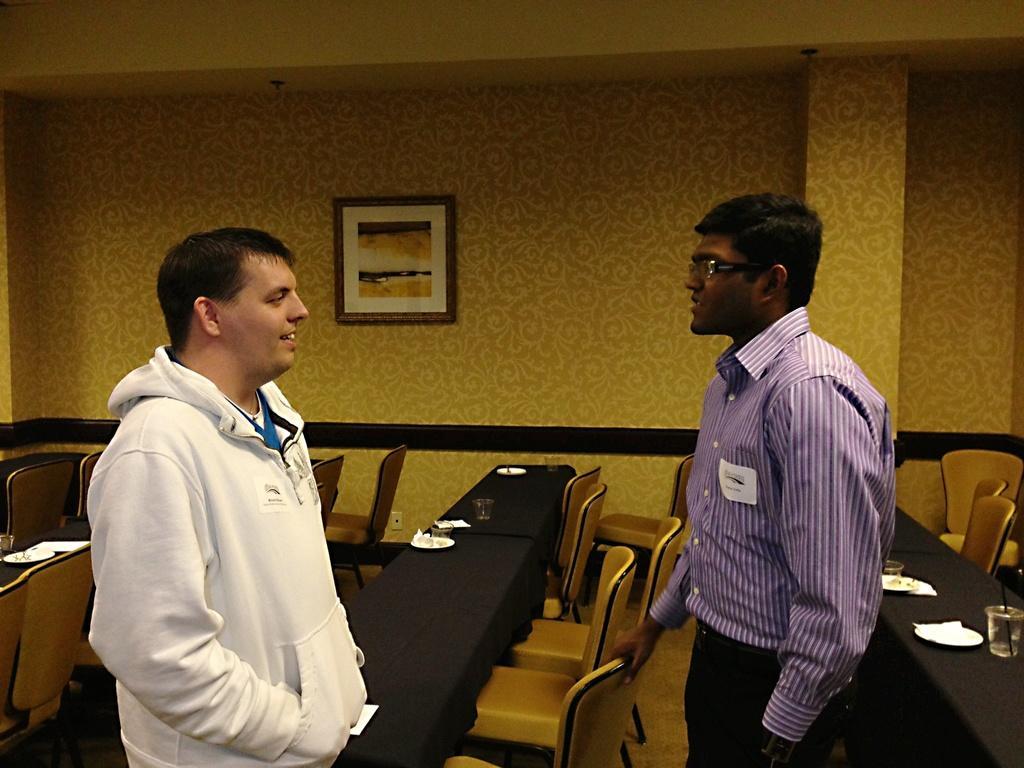Can you describe this image briefly? As we can see in the image there is a wall, photo frame, two people standing over here and there are chairs and tables. On tables there are plates and glasses. 